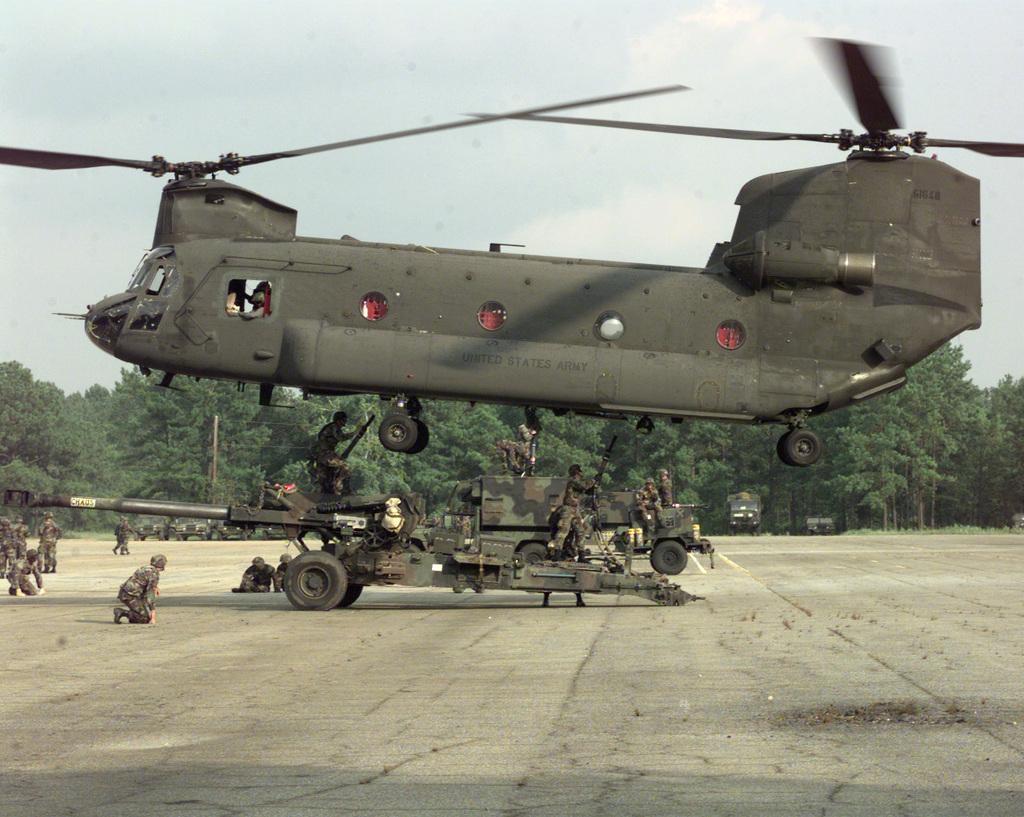Can you describe this image briefly? In the picture I can see a helicopter is flying in the air and vehicles on the ground. I can also see people among them some are on the ground and some are in vehicles. In the background I can see trees, the sky and some other objects. 